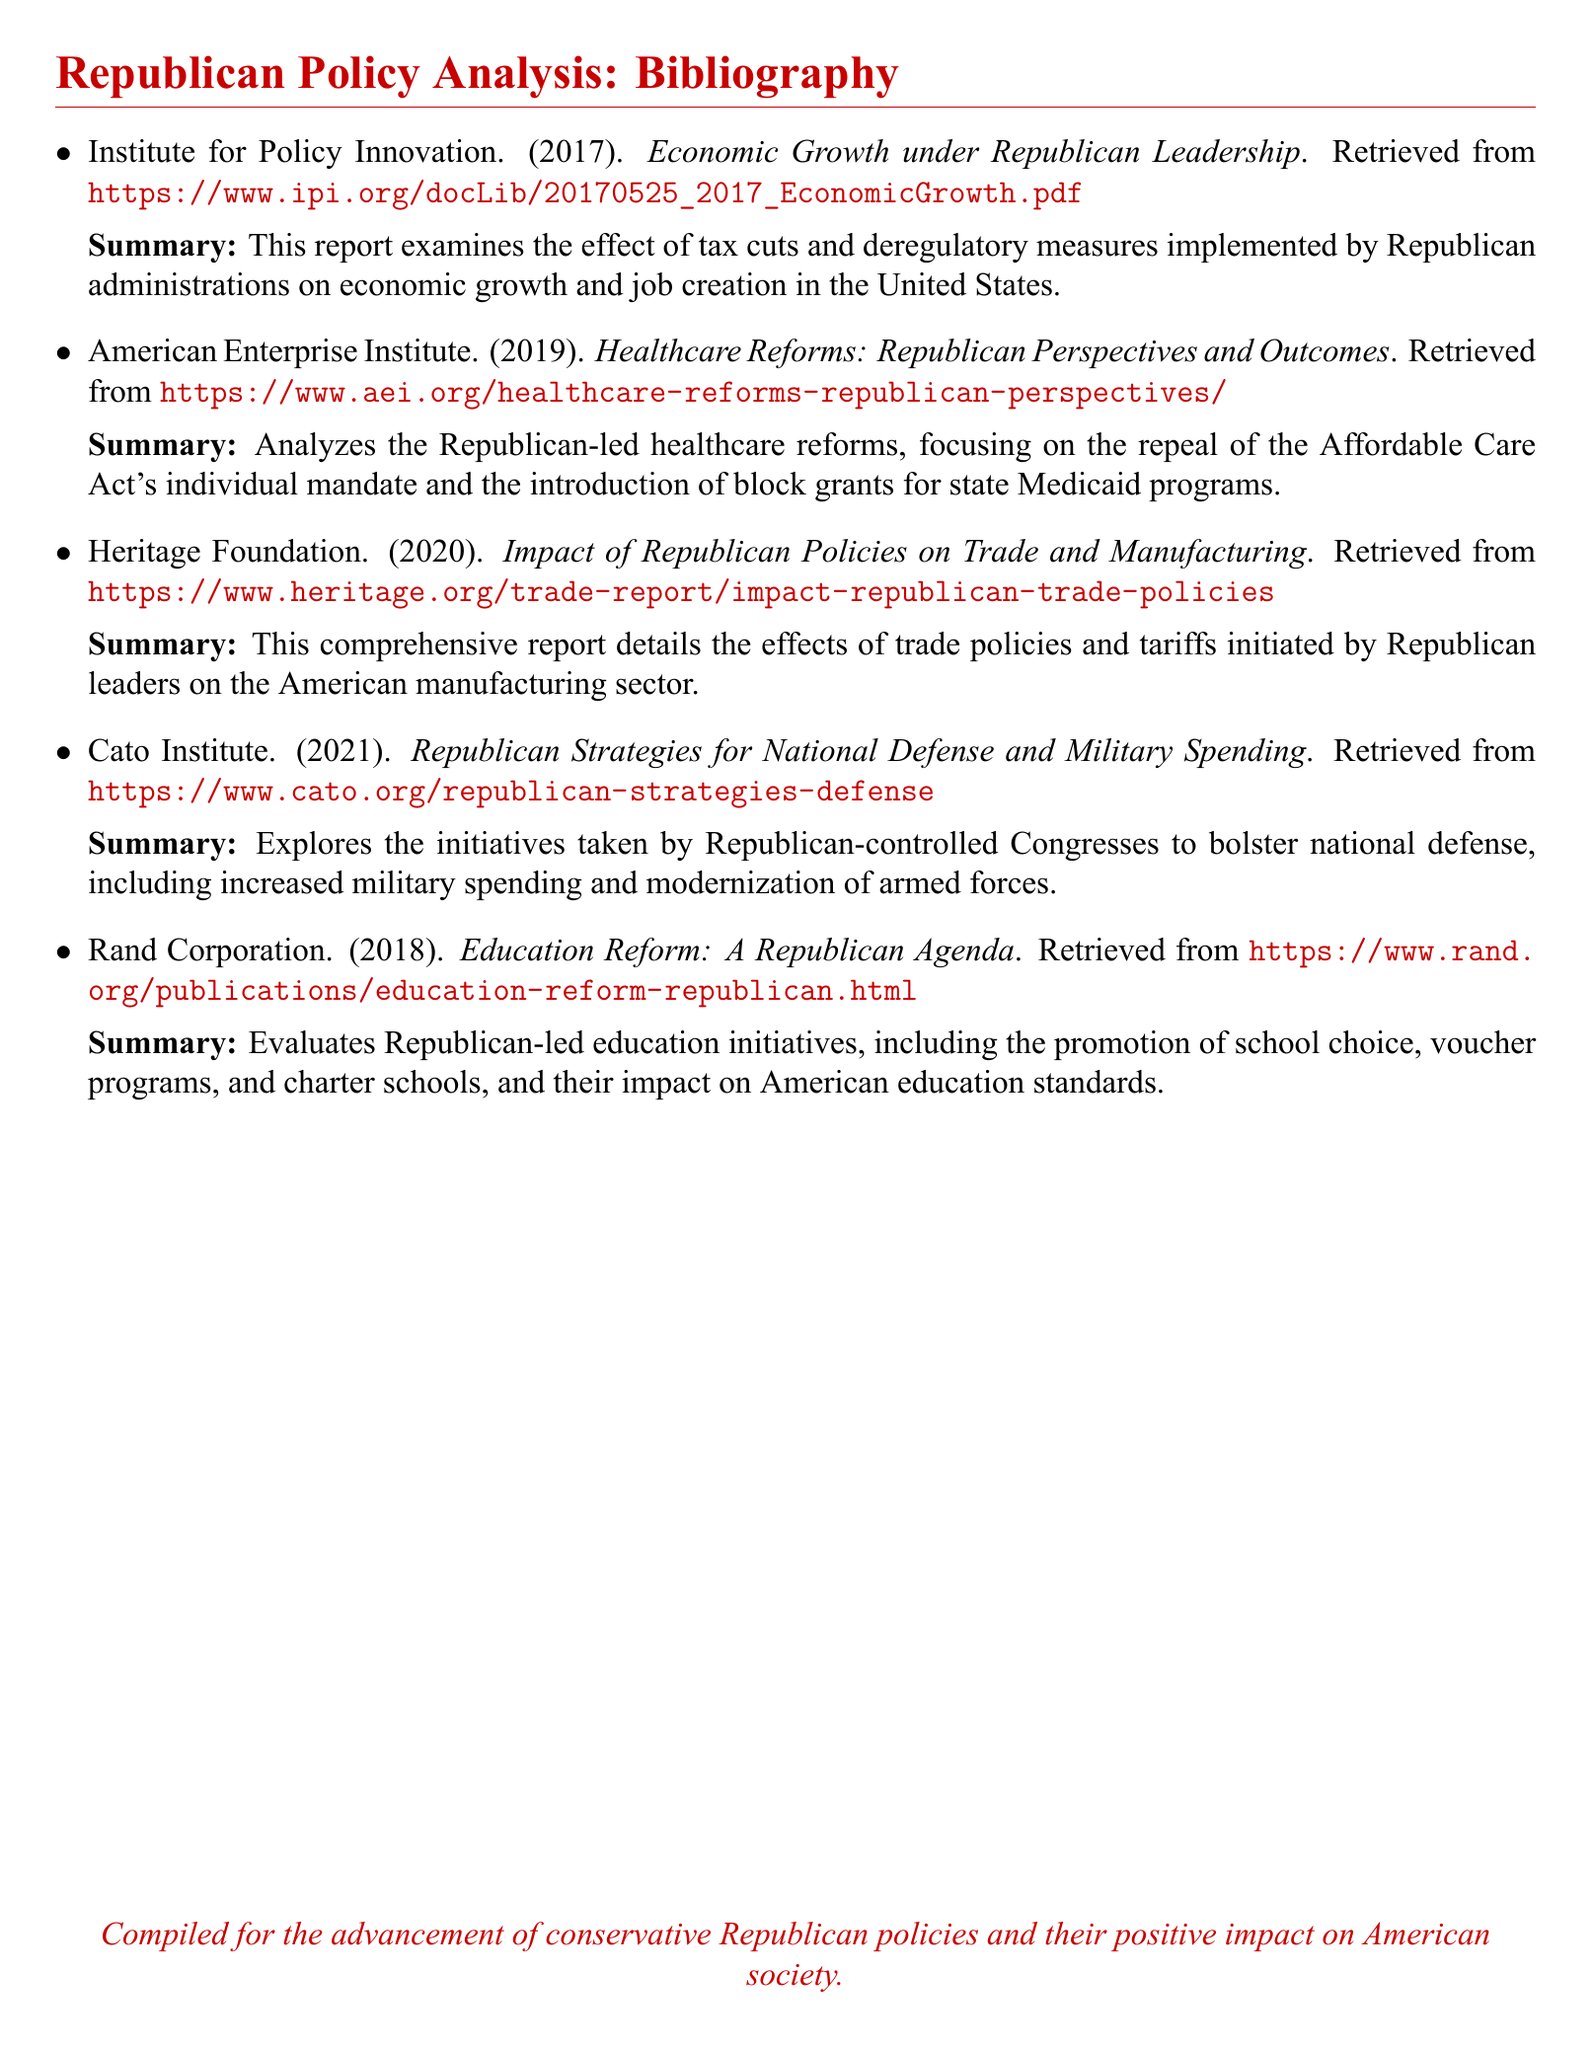What organization published the report on economic growth? The report on economic growth is published by the Institute for Policy Innovation.
Answer: Institute for Policy Innovation What year was the healthcare reforms report published? The healthcare reforms report was published in 2019.
Answer: 2019 What is the primary focus of the Rand Corporation's report? The primary focus is on Republican-led education initiatives such as school choice and voucher programs.
Answer: Education reform How many reports are listed in the bibliography? The bibliography lists a total of five reports.
Answer: Five Which organization explored the impact of Republican trade policies? The organization that explored the impact of Republican trade policies is the Heritage Foundation.
Answer: Heritage Foundation What is the main topic of the report by the Cato Institute? The Cato Institute's report focuses on national defense and military spending strategies.
Answer: National defense What type of measures does the report on economic growth discuss? The report discusses tax cuts and deregulatory measures.
Answer: Tax cuts and deregulatory measures What color is used for the text in the title section? The color used for the text in the title section is Republican red.
Answer: Republican red What is the purpose of compiling these reports? The purpose is for the advancement of conservative Republican policies and their positive impact on American society.
Answer: Advancement of conservative Republican policies 